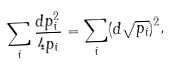<formula> <loc_0><loc_0><loc_500><loc_500>\sum _ { i } \frac { d p _ { i } ^ { 2 } } { 4 p _ { i } } = \sum _ { i } ( d \sqrt { p _ { i } } ) ^ { 2 } ,</formula> 